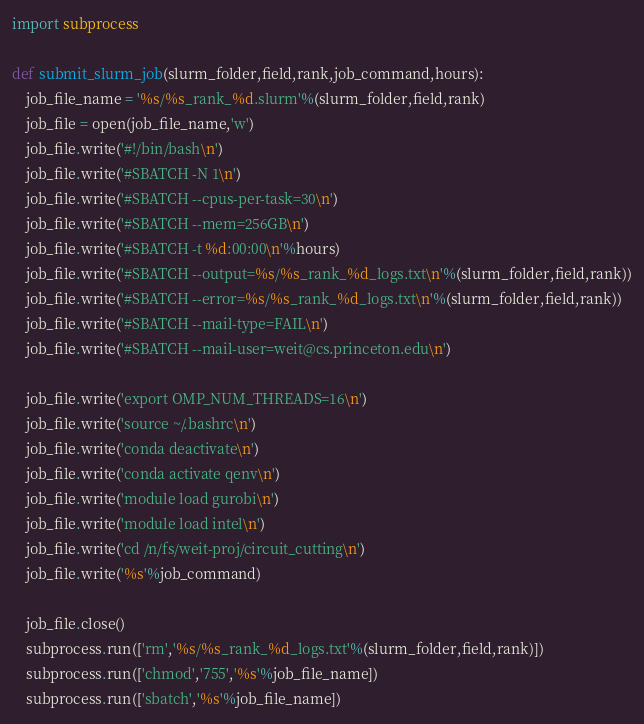Convert code to text. <code><loc_0><loc_0><loc_500><loc_500><_Python_>import subprocess

def submit_slurm_job(slurm_folder,field,rank,job_command,hours):
    job_file_name = '%s/%s_rank_%d.slurm'%(slurm_folder,field,rank)
    job_file = open(job_file_name,'w')
    job_file.write('#!/bin/bash\n')
    job_file.write('#SBATCH -N 1\n')
    job_file.write('#SBATCH --cpus-per-task=30\n')
    job_file.write('#SBATCH --mem=256GB\n')
    job_file.write('#SBATCH -t %d:00:00\n'%hours)
    job_file.write('#SBATCH --output=%s/%s_rank_%d_logs.txt\n'%(slurm_folder,field,rank))
    job_file.write('#SBATCH --error=%s/%s_rank_%d_logs.txt\n'%(slurm_folder,field,rank))
    job_file.write('#SBATCH --mail-type=FAIL\n')
    job_file.write('#SBATCH --mail-user=weit@cs.princeton.edu\n')
    
    job_file.write('export OMP_NUM_THREADS=16\n')
    job_file.write('source ~/.bashrc\n')
    job_file.write('conda deactivate\n')
    job_file.write('conda activate qenv\n')
    job_file.write('module load gurobi\n')
    job_file.write('module load intel\n')
    job_file.write('cd /n/fs/weit-proj/circuit_cutting\n')
    job_file.write('%s'%job_command)

    job_file.close()
    subprocess.run(['rm','%s/%s_rank_%d_logs.txt'%(slurm_folder,field,rank)])
    subprocess.run(['chmod','755','%s'%job_file_name])
    subprocess.run(['sbatch','%s'%job_file_name])</code> 